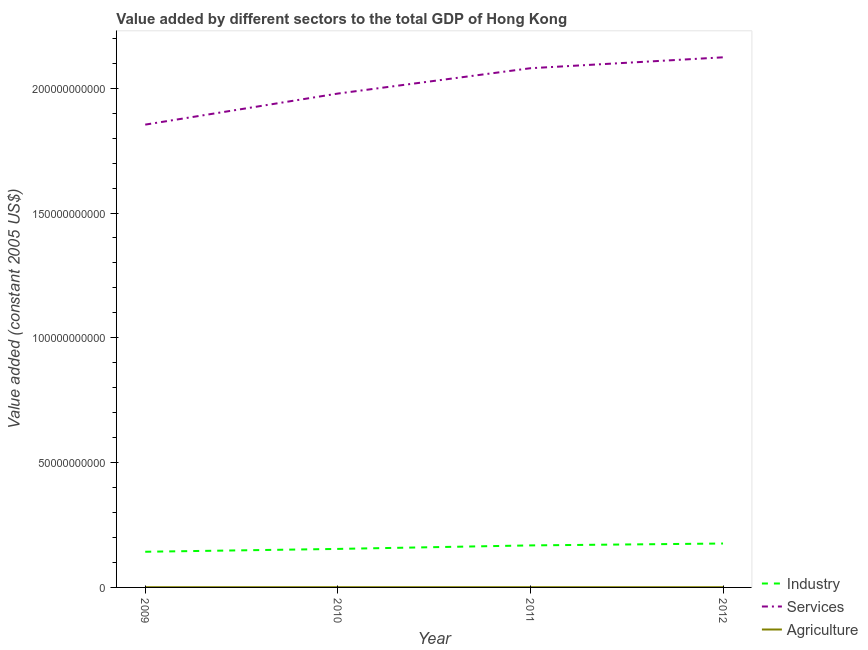Does the line corresponding to value added by agricultural sector intersect with the line corresponding to value added by industrial sector?
Offer a very short reply. No. Is the number of lines equal to the number of legend labels?
Provide a short and direct response. Yes. What is the value added by agricultural sector in 2010?
Your answer should be compact. 9.32e+07. Across all years, what is the maximum value added by agricultural sector?
Your response must be concise. 9.38e+07. Across all years, what is the minimum value added by agricultural sector?
Ensure brevity in your answer.  8.99e+07. In which year was the value added by agricultural sector minimum?
Offer a terse response. 2009. What is the total value added by services in the graph?
Offer a terse response. 8.04e+11. What is the difference between the value added by services in 2009 and that in 2011?
Give a very brief answer. -2.26e+1. What is the difference between the value added by industrial sector in 2010 and the value added by agricultural sector in 2012?
Your answer should be very brief. 1.53e+1. What is the average value added by industrial sector per year?
Your answer should be very brief. 1.60e+1. In the year 2010, what is the difference between the value added by industrial sector and value added by agricultural sector?
Give a very brief answer. 1.53e+1. What is the ratio of the value added by agricultural sector in 2009 to that in 2010?
Make the answer very short. 0.96. Is the difference between the value added by services in 2010 and 2011 greater than the difference between the value added by agricultural sector in 2010 and 2011?
Offer a very short reply. No. What is the difference between the highest and the second highest value added by services?
Give a very brief answer. 4.37e+09. What is the difference between the highest and the lowest value added by industrial sector?
Make the answer very short. 3.30e+09. Is it the case that in every year, the sum of the value added by industrial sector and value added by services is greater than the value added by agricultural sector?
Keep it short and to the point. Yes. Is the value added by agricultural sector strictly greater than the value added by industrial sector over the years?
Keep it short and to the point. No. How many lines are there?
Your answer should be compact. 3. How many years are there in the graph?
Offer a terse response. 4. Does the graph contain any zero values?
Provide a succinct answer. No. Where does the legend appear in the graph?
Provide a short and direct response. Bottom right. How many legend labels are there?
Give a very brief answer. 3. What is the title of the graph?
Make the answer very short. Value added by different sectors to the total GDP of Hong Kong. What is the label or title of the Y-axis?
Your response must be concise. Value added (constant 2005 US$). What is the Value added (constant 2005 US$) in Industry in 2009?
Offer a terse response. 1.43e+1. What is the Value added (constant 2005 US$) in Services in 2009?
Make the answer very short. 1.85e+11. What is the Value added (constant 2005 US$) of Agriculture in 2009?
Provide a short and direct response. 8.99e+07. What is the Value added (constant 2005 US$) in Industry in 2010?
Your response must be concise. 1.54e+1. What is the Value added (constant 2005 US$) of Services in 2010?
Your response must be concise. 1.98e+11. What is the Value added (constant 2005 US$) of Agriculture in 2010?
Give a very brief answer. 9.32e+07. What is the Value added (constant 2005 US$) of Industry in 2011?
Your answer should be compact. 1.68e+1. What is the Value added (constant 2005 US$) of Services in 2011?
Your answer should be compact. 2.08e+11. What is the Value added (constant 2005 US$) of Agriculture in 2011?
Offer a terse response. 9.38e+07. What is the Value added (constant 2005 US$) of Industry in 2012?
Keep it short and to the point. 1.76e+1. What is the Value added (constant 2005 US$) of Services in 2012?
Provide a succinct answer. 2.12e+11. What is the Value added (constant 2005 US$) in Agriculture in 2012?
Ensure brevity in your answer.  9.11e+07. Across all years, what is the maximum Value added (constant 2005 US$) of Industry?
Provide a succinct answer. 1.76e+1. Across all years, what is the maximum Value added (constant 2005 US$) of Services?
Keep it short and to the point. 2.12e+11. Across all years, what is the maximum Value added (constant 2005 US$) in Agriculture?
Your response must be concise. 9.38e+07. Across all years, what is the minimum Value added (constant 2005 US$) in Industry?
Provide a short and direct response. 1.43e+1. Across all years, what is the minimum Value added (constant 2005 US$) of Services?
Give a very brief answer. 1.85e+11. Across all years, what is the minimum Value added (constant 2005 US$) of Agriculture?
Your answer should be compact. 8.99e+07. What is the total Value added (constant 2005 US$) of Industry in the graph?
Provide a succinct answer. 6.42e+1. What is the total Value added (constant 2005 US$) of Services in the graph?
Offer a terse response. 8.04e+11. What is the total Value added (constant 2005 US$) of Agriculture in the graph?
Ensure brevity in your answer.  3.68e+08. What is the difference between the Value added (constant 2005 US$) in Industry in 2009 and that in 2010?
Ensure brevity in your answer.  -1.14e+09. What is the difference between the Value added (constant 2005 US$) of Services in 2009 and that in 2010?
Offer a very short reply. -1.24e+1. What is the difference between the Value added (constant 2005 US$) of Agriculture in 2009 and that in 2010?
Keep it short and to the point. -3.35e+06. What is the difference between the Value added (constant 2005 US$) of Industry in 2009 and that in 2011?
Ensure brevity in your answer.  -2.54e+09. What is the difference between the Value added (constant 2005 US$) in Services in 2009 and that in 2011?
Your response must be concise. -2.26e+1. What is the difference between the Value added (constant 2005 US$) in Agriculture in 2009 and that in 2011?
Offer a very short reply. -3.98e+06. What is the difference between the Value added (constant 2005 US$) of Industry in 2009 and that in 2012?
Your answer should be compact. -3.30e+09. What is the difference between the Value added (constant 2005 US$) in Services in 2009 and that in 2012?
Provide a short and direct response. -2.70e+1. What is the difference between the Value added (constant 2005 US$) in Agriculture in 2009 and that in 2012?
Offer a terse response. -1.25e+06. What is the difference between the Value added (constant 2005 US$) of Industry in 2010 and that in 2011?
Provide a succinct answer. -1.41e+09. What is the difference between the Value added (constant 2005 US$) in Services in 2010 and that in 2011?
Make the answer very short. -1.02e+1. What is the difference between the Value added (constant 2005 US$) of Agriculture in 2010 and that in 2011?
Keep it short and to the point. -6.24e+05. What is the difference between the Value added (constant 2005 US$) in Industry in 2010 and that in 2012?
Provide a succinct answer. -2.16e+09. What is the difference between the Value added (constant 2005 US$) of Services in 2010 and that in 2012?
Your answer should be very brief. -1.45e+1. What is the difference between the Value added (constant 2005 US$) in Agriculture in 2010 and that in 2012?
Your response must be concise. 2.11e+06. What is the difference between the Value added (constant 2005 US$) of Industry in 2011 and that in 2012?
Give a very brief answer. -7.55e+08. What is the difference between the Value added (constant 2005 US$) in Services in 2011 and that in 2012?
Provide a succinct answer. -4.37e+09. What is the difference between the Value added (constant 2005 US$) of Agriculture in 2011 and that in 2012?
Provide a succinct answer. 2.73e+06. What is the difference between the Value added (constant 2005 US$) in Industry in 2009 and the Value added (constant 2005 US$) in Services in 2010?
Your answer should be compact. -1.84e+11. What is the difference between the Value added (constant 2005 US$) of Industry in 2009 and the Value added (constant 2005 US$) of Agriculture in 2010?
Provide a short and direct response. 1.42e+1. What is the difference between the Value added (constant 2005 US$) in Services in 2009 and the Value added (constant 2005 US$) in Agriculture in 2010?
Provide a short and direct response. 1.85e+11. What is the difference between the Value added (constant 2005 US$) of Industry in 2009 and the Value added (constant 2005 US$) of Services in 2011?
Keep it short and to the point. -1.94e+11. What is the difference between the Value added (constant 2005 US$) in Industry in 2009 and the Value added (constant 2005 US$) in Agriculture in 2011?
Your answer should be very brief. 1.42e+1. What is the difference between the Value added (constant 2005 US$) of Services in 2009 and the Value added (constant 2005 US$) of Agriculture in 2011?
Make the answer very short. 1.85e+11. What is the difference between the Value added (constant 2005 US$) in Industry in 2009 and the Value added (constant 2005 US$) in Services in 2012?
Offer a terse response. -1.98e+11. What is the difference between the Value added (constant 2005 US$) in Industry in 2009 and the Value added (constant 2005 US$) in Agriculture in 2012?
Offer a very short reply. 1.42e+1. What is the difference between the Value added (constant 2005 US$) in Services in 2009 and the Value added (constant 2005 US$) in Agriculture in 2012?
Offer a very short reply. 1.85e+11. What is the difference between the Value added (constant 2005 US$) in Industry in 2010 and the Value added (constant 2005 US$) in Services in 2011?
Your response must be concise. -1.93e+11. What is the difference between the Value added (constant 2005 US$) in Industry in 2010 and the Value added (constant 2005 US$) in Agriculture in 2011?
Provide a short and direct response. 1.53e+1. What is the difference between the Value added (constant 2005 US$) in Services in 2010 and the Value added (constant 2005 US$) in Agriculture in 2011?
Ensure brevity in your answer.  1.98e+11. What is the difference between the Value added (constant 2005 US$) of Industry in 2010 and the Value added (constant 2005 US$) of Services in 2012?
Give a very brief answer. -1.97e+11. What is the difference between the Value added (constant 2005 US$) in Industry in 2010 and the Value added (constant 2005 US$) in Agriculture in 2012?
Provide a short and direct response. 1.53e+1. What is the difference between the Value added (constant 2005 US$) of Services in 2010 and the Value added (constant 2005 US$) of Agriculture in 2012?
Your response must be concise. 1.98e+11. What is the difference between the Value added (constant 2005 US$) of Industry in 2011 and the Value added (constant 2005 US$) of Services in 2012?
Give a very brief answer. -1.96e+11. What is the difference between the Value added (constant 2005 US$) in Industry in 2011 and the Value added (constant 2005 US$) in Agriculture in 2012?
Your response must be concise. 1.67e+1. What is the difference between the Value added (constant 2005 US$) of Services in 2011 and the Value added (constant 2005 US$) of Agriculture in 2012?
Keep it short and to the point. 2.08e+11. What is the average Value added (constant 2005 US$) in Industry per year?
Your response must be concise. 1.60e+1. What is the average Value added (constant 2005 US$) in Services per year?
Make the answer very short. 2.01e+11. What is the average Value added (constant 2005 US$) in Agriculture per year?
Provide a short and direct response. 9.20e+07. In the year 2009, what is the difference between the Value added (constant 2005 US$) of Industry and Value added (constant 2005 US$) of Services?
Keep it short and to the point. -1.71e+11. In the year 2009, what is the difference between the Value added (constant 2005 US$) in Industry and Value added (constant 2005 US$) in Agriculture?
Your answer should be very brief. 1.42e+1. In the year 2009, what is the difference between the Value added (constant 2005 US$) in Services and Value added (constant 2005 US$) in Agriculture?
Your response must be concise. 1.85e+11. In the year 2010, what is the difference between the Value added (constant 2005 US$) in Industry and Value added (constant 2005 US$) in Services?
Provide a short and direct response. -1.82e+11. In the year 2010, what is the difference between the Value added (constant 2005 US$) of Industry and Value added (constant 2005 US$) of Agriculture?
Provide a short and direct response. 1.53e+1. In the year 2010, what is the difference between the Value added (constant 2005 US$) of Services and Value added (constant 2005 US$) of Agriculture?
Offer a very short reply. 1.98e+11. In the year 2011, what is the difference between the Value added (constant 2005 US$) in Industry and Value added (constant 2005 US$) in Services?
Offer a terse response. -1.91e+11. In the year 2011, what is the difference between the Value added (constant 2005 US$) in Industry and Value added (constant 2005 US$) in Agriculture?
Ensure brevity in your answer.  1.67e+1. In the year 2011, what is the difference between the Value added (constant 2005 US$) of Services and Value added (constant 2005 US$) of Agriculture?
Offer a very short reply. 2.08e+11. In the year 2012, what is the difference between the Value added (constant 2005 US$) in Industry and Value added (constant 2005 US$) in Services?
Offer a terse response. -1.95e+11. In the year 2012, what is the difference between the Value added (constant 2005 US$) in Industry and Value added (constant 2005 US$) in Agriculture?
Your answer should be compact. 1.75e+1. In the year 2012, what is the difference between the Value added (constant 2005 US$) in Services and Value added (constant 2005 US$) in Agriculture?
Offer a terse response. 2.12e+11. What is the ratio of the Value added (constant 2005 US$) of Industry in 2009 to that in 2010?
Make the answer very short. 0.93. What is the ratio of the Value added (constant 2005 US$) of Services in 2009 to that in 2010?
Provide a succinct answer. 0.94. What is the ratio of the Value added (constant 2005 US$) of Agriculture in 2009 to that in 2010?
Give a very brief answer. 0.96. What is the ratio of the Value added (constant 2005 US$) in Industry in 2009 to that in 2011?
Provide a succinct answer. 0.85. What is the ratio of the Value added (constant 2005 US$) in Services in 2009 to that in 2011?
Offer a very short reply. 0.89. What is the ratio of the Value added (constant 2005 US$) in Agriculture in 2009 to that in 2011?
Your answer should be compact. 0.96. What is the ratio of the Value added (constant 2005 US$) in Industry in 2009 to that in 2012?
Your answer should be very brief. 0.81. What is the ratio of the Value added (constant 2005 US$) of Services in 2009 to that in 2012?
Keep it short and to the point. 0.87. What is the ratio of the Value added (constant 2005 US$) in Agriculture in 2009 to that in 2012?
Ensure brevity in your answer.  0.99. What is the ratio of the Value added (constant 2005 US$) in Industry in 2010 to that in 2011?
Your answer should be very brief. 0.92. What is the ratio of the Value added (constant 2005 US$) in Services in 2010 to that in 2011?
Ensure brevity in your answer.  0.95. What is the ratio of the Value added (constant 2005 US$) in Agriculture in 2010 to that in 2011?
Make the answer very short. 0.99. What is the ratio of the Value added (constant 2005 US$) of Industry in 2010 to that in 2012?
Provide a short and direct response. 0.88. What is the ratio of the Value added (constant 2005 US$) in Services in 2010 to that in 2012?
Ensure brevity in your answer.  0.93. What is the ratio of the Value added (constant 2005 US$) of Agriculture in 2010 to that in 2012?
Your response must be concise. 1.02. What is the ratio of the Value added (constant 2005 US$) of Industry in 2011 to that in 2012?
Offer a terse response. 0.96. What is the ratio of the Value added (constant 2005 US$) of Services in 2011 to that in 2012?
Keep it short and to the point. 0.98. What is the ratio of the Value added (constant 2005 US$) in Agriculture in 2011 to that in 2012?
Ensure brevity in your answer.  1.03. What is the difference between the highest and the second highest Value added (constant 2005 US$) of Industry?
Your answer should be compact. 7.55e+08. What is the difference between the highest and the second highest Value added (constant 2005 US$) in Services?
Provide a short and direct response. 4.37e+09. What is the difference between the highest and the second highest Value added (constant 2005 US$) in Agriculture?
Provide a succinct answer. 6.24e+05. What is the difference between the highest and the lowest Value added (constant 2005 US$) in Industry?
Your answer should be compact. 3.30e+09. What is the difference between the highest and the lowest Value added (constant 2005 US$) in Services?
Ensure brevity in your answer.  2.70e+1. What is the difference between the highest and the lowest Value added (constant 2005 US$) in Agriculture?
Give a very brief answer. 3.98e+06. 